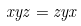<formula> <loc_0><loc_0><loc_500><loc_500>x y z = z y x</formula> 